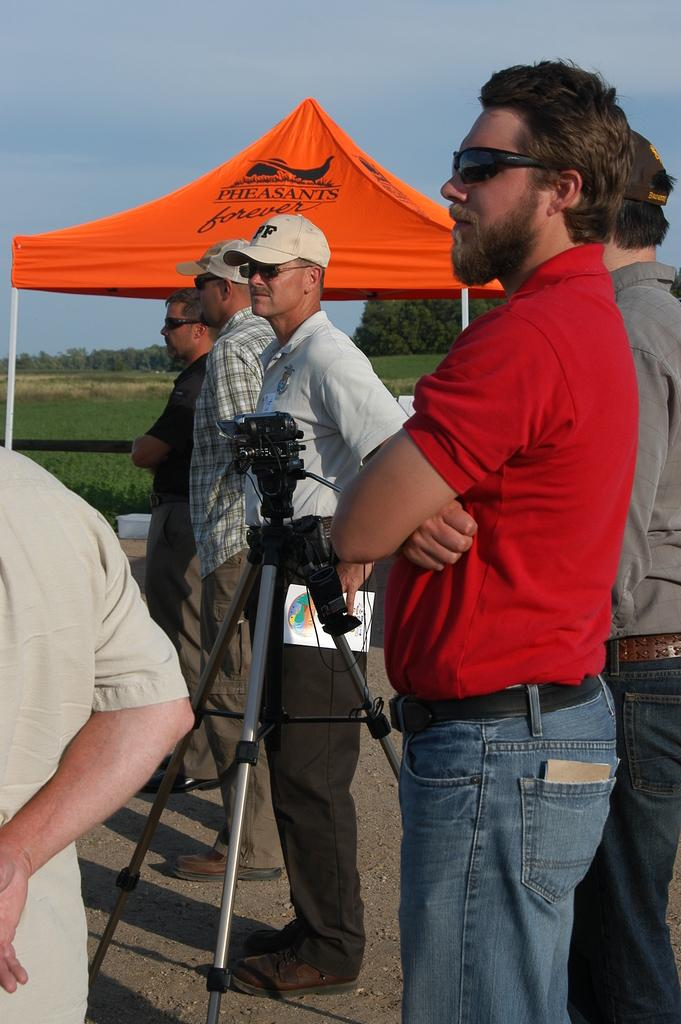What are the people in the image doing? The persons in the image are standing on the road. What equipment is present in the image? There is a camera with a stand in the image. What type of vegetation can be seen in the image? Trees and grass are visible in the image. What is visible at the top of the image? The sky is visible at the top of the image. Can you tell me how many times the person sneezed while taking the photo in the image? There is no indication of anyone sneezing in the image, as it features people standing on the road and a camera with a stand. Is the person swimming in the image? There is no person swimming in the image; the image shows people standing on the road and a camera with a stand. 